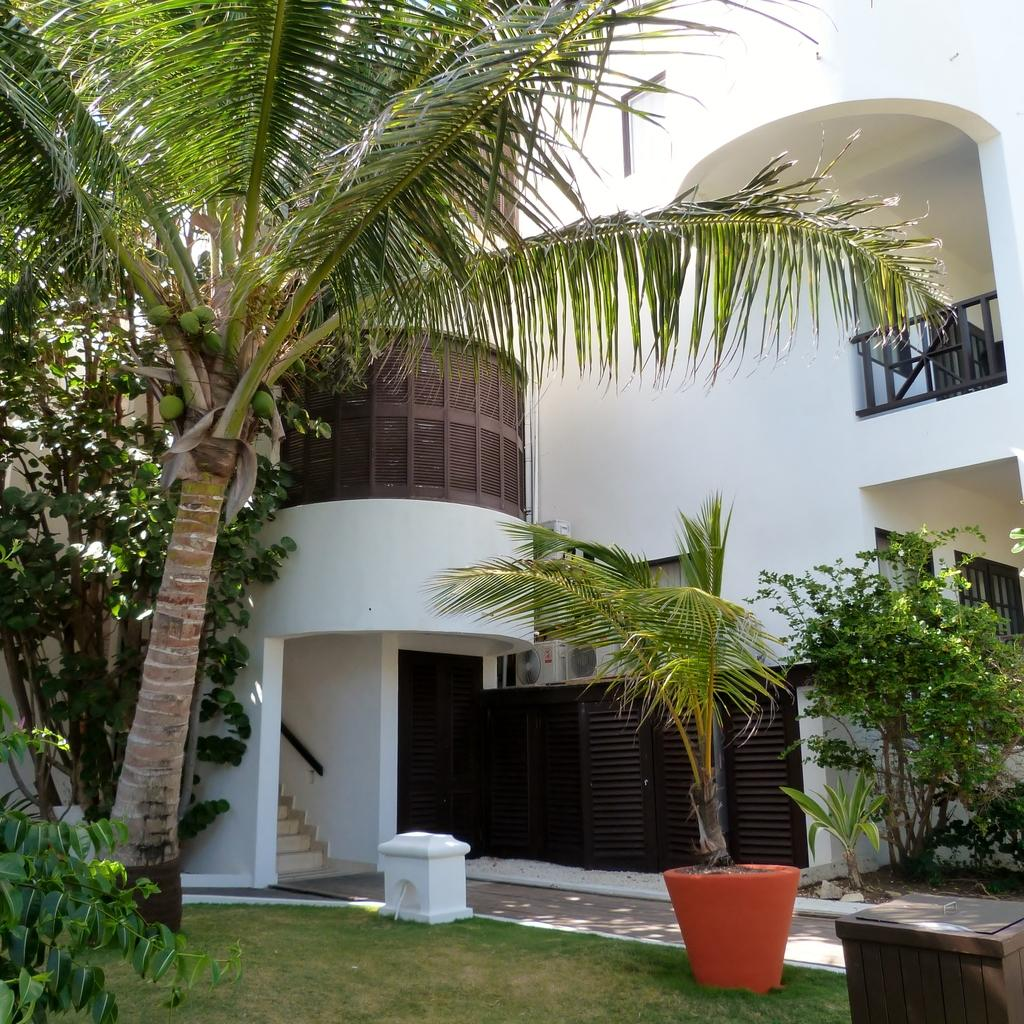What type of structure is visible in the image? There is a building in the image. What natural elements can be seen in the image? There are trees and plants in the image. Can you describe an object on the right side of the image? There is a stool on the right side of the image. What type of bells can be heard ringing in the image? There are no bells present in the image, and therefore no sounds can be heard. Can you tell me how many calculators are visible on the stool? There are no calculators present in the image; only a stool is visible. 